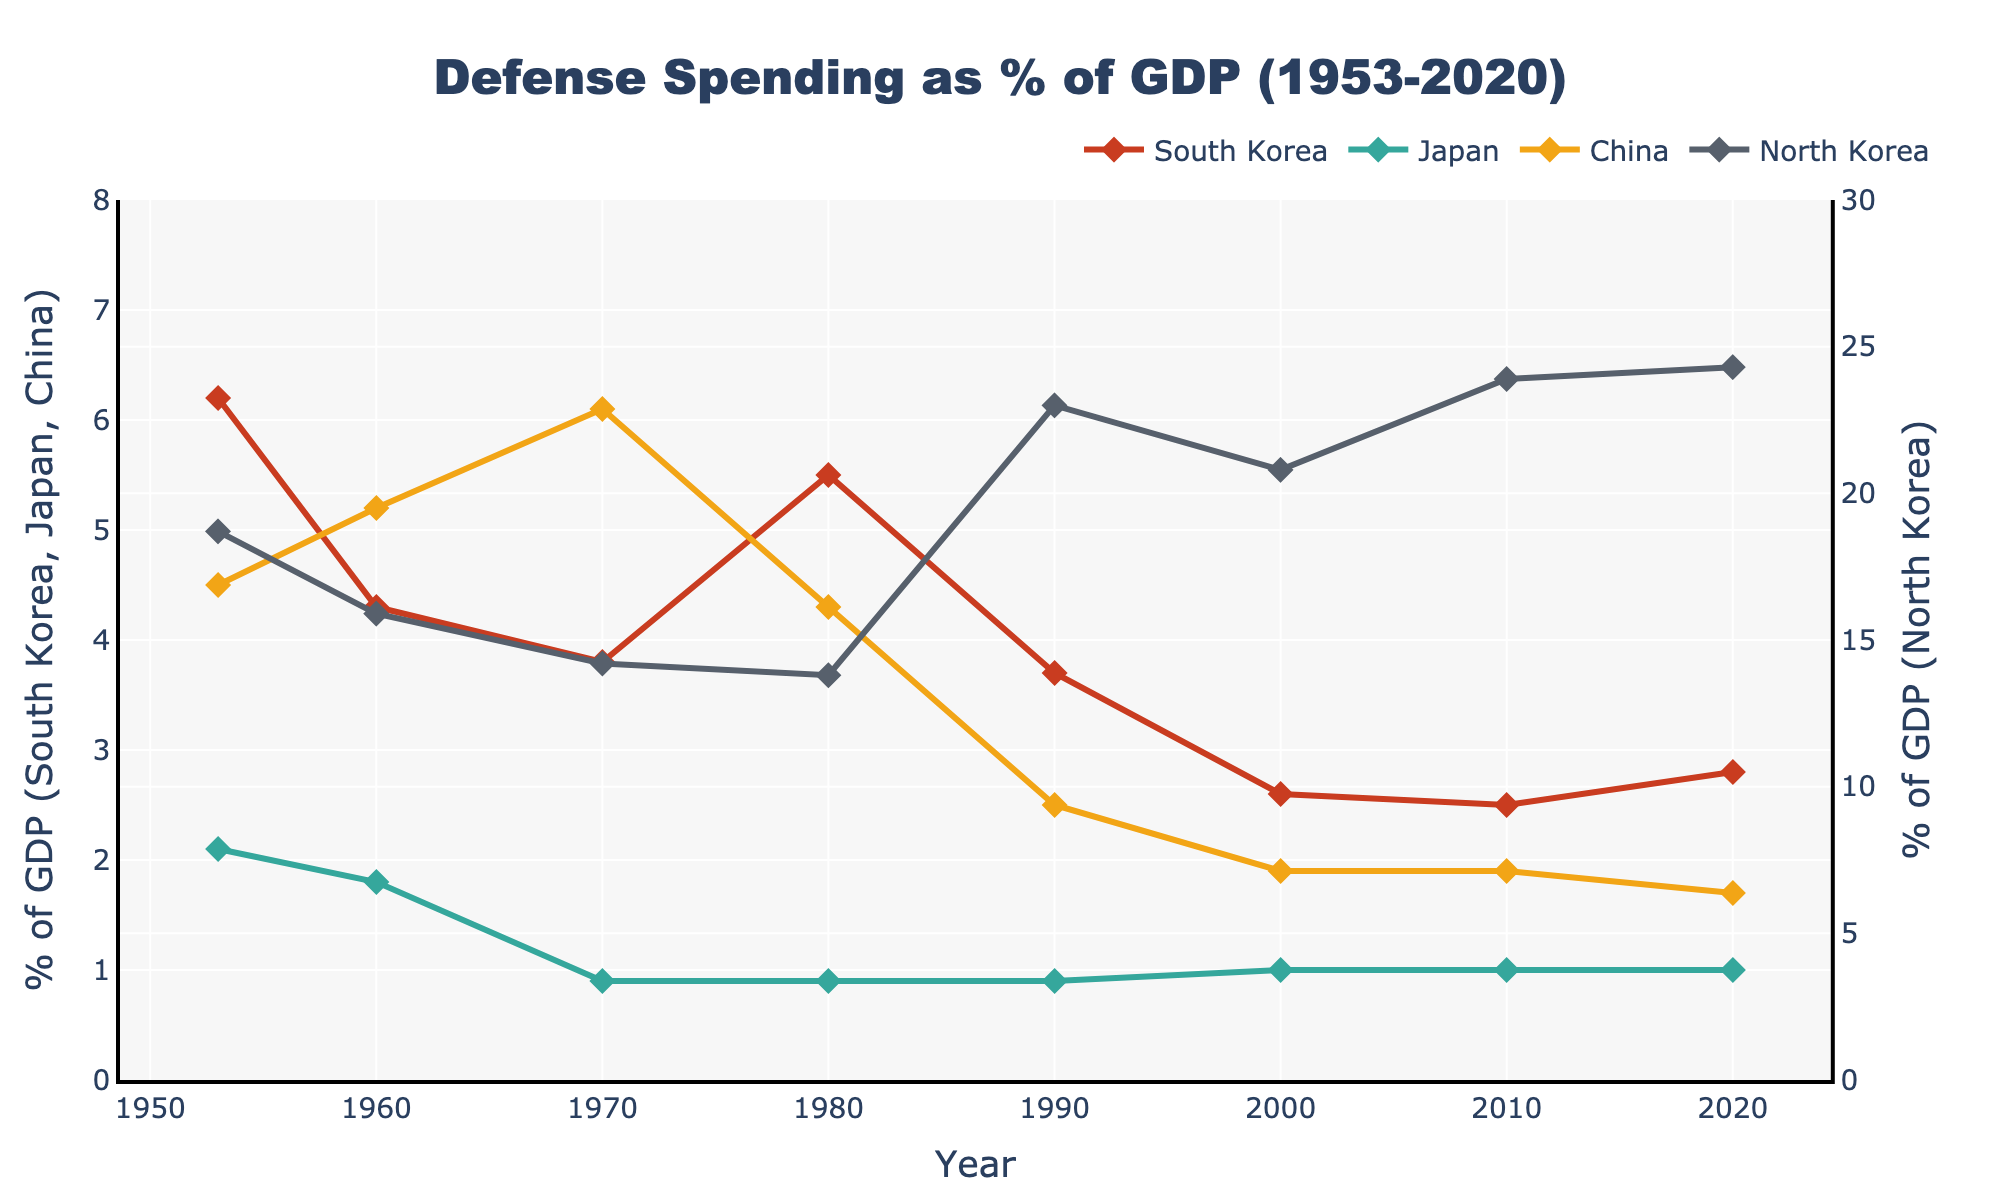What was the trend in South Korea's defense spending as a percentage of GDP from 1953 to 2020? South Korea's defense spending shows a generally decreasing trend from 1953 (6.2%) to 2020 (2.8%) with some fluctuations. For instance, it decreased significantly from 1953 to 1960, remained relatively stable between 1970 and 2000, and showed a slight increase between 2000 and 2020.
Answer: Generally decreasing Compared to Japan, did South Korea spend a higher percentage of its GDP on defense in 1980? In 1980, South Korea's defense spending as a percentage of GDP was 5.5%, while Japan's was only 0.9%. By comparing these two values, it is clear that South Korea spent a higher percentage of its GDP on defense compared to Japan in that year.
Answer: Yes How did China’s defense spending as a percentage of GDP change between 1953 and 2020? China's defense spending was at 4.5% in 1953, increased to 6.1% by 1970, then decreased to 1.7% by 2020. We can see an initial increase and a fairly consistent decrease thereafter.
Answer: Decreased Which country had the highest defense spending as a percentage of GDP in 1990? In 1990, North Korea had the highest defense spending as a percentage of GDP at 23.0%, much higher than South Korea (3.7%), Japan (0.9%), and China (2.5%).
Answer: North Korea What was the difference in defense spending as a percentage of GDP between North Korea and South Korea in 2020? In 2020, North Korea's defense spending as a percentage of GDP was 24.3%, while South Korea's was 2.8%. The difference is 24.3% - 2.8% = 21.5%.
Answer: 21.5% By how much did South Korea's defense spending as a percentage of GDP decrease from 1953 to 2000? South Korea's defense spending was 6.2% in 1953 and decreased to 2.6% in 2000. The decrease can be calculated as 6.2% - 2.6% = 3.6%.
Answer: 3.6% Was there any year where Japan's defense spending as a percentage of GDP was higher than 1%? If so, which year(s)? According to the data, Japan's defense spending as a percentage of GDP remained relatively constant at or below 1% from 1953 to 2020.
Answer: No What decade showed the most significant decline in defense spending for South Korea? The most significant decline in South Korea's defense spending occurred between the 1950s and 1960s, where it dropped from 6.2% in 1953 to 4.3% in 1960. This is the largest change observed over a decade.
Answer: 1950s-1960s How does the color of the lines help distinguish each country's defense spending on the chart? The lines on the chart are colored differently to distinguish each country: South Korea (red), Japan (green), China (yellow), and North Korea (grey). These distinct colors help in visually separating and identifying the trends for each country.
Answer: Different colors 